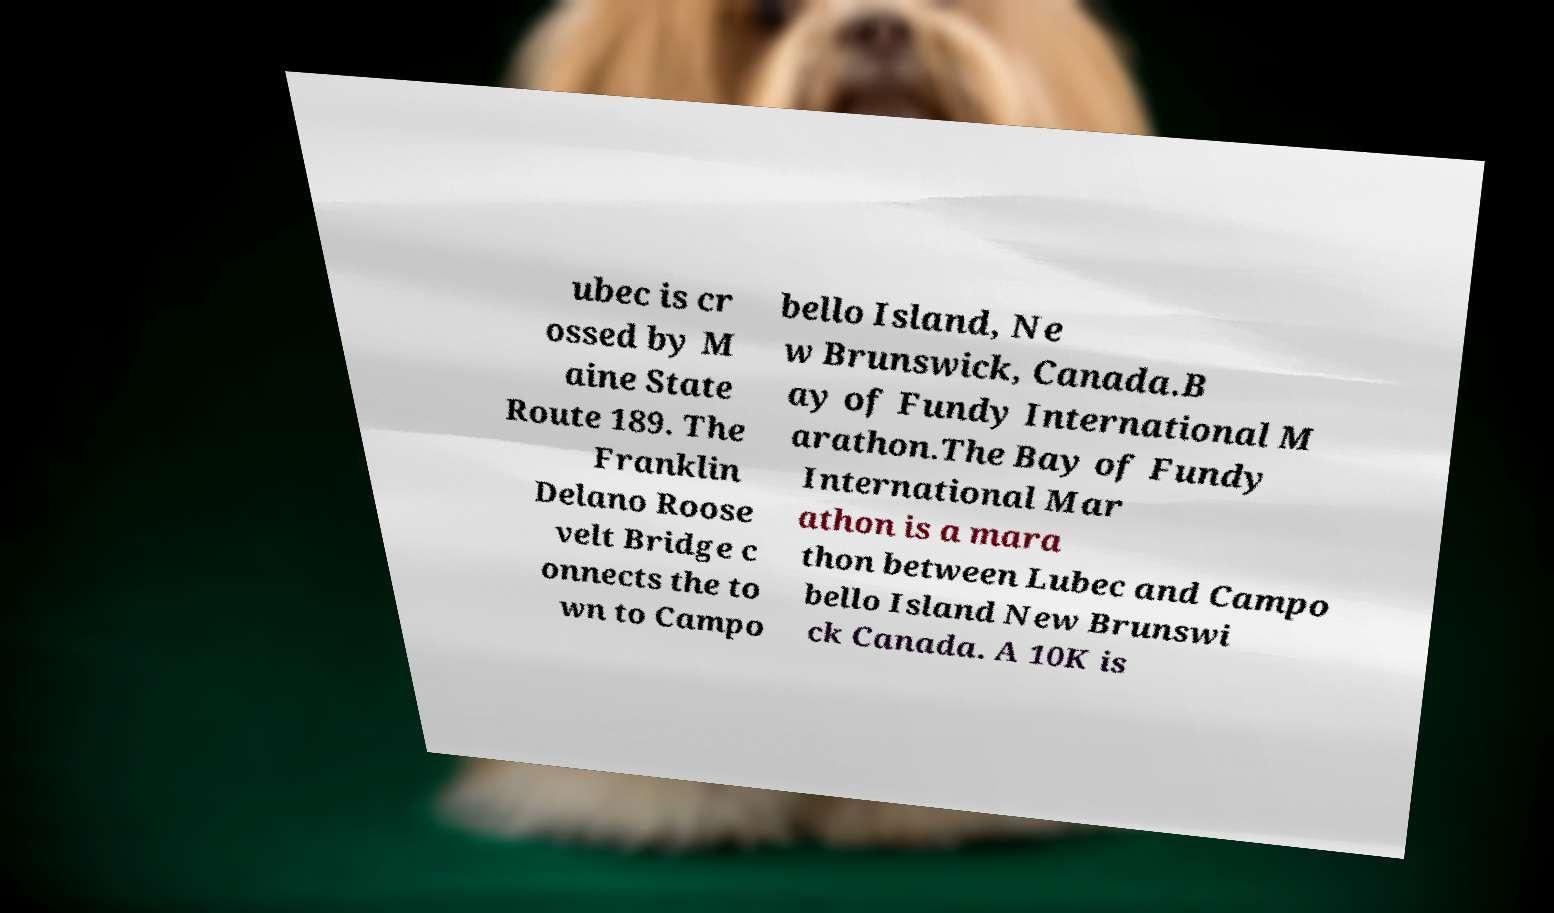Could you assist in decoding the text presented in this image and type it out clearly? ubec is cr ossed by M aine State Route 189. The Franklin Delano Roose velt Bridge c onnects the to wn to Campo bello Island, Ne w Brunswick, Canada.B ay of Fundy International M arathon.The Bay of Fundy International Mar athon is a mara thon between Lubec and Campo bello Island New Brunswi ck Canada. A 10K is 